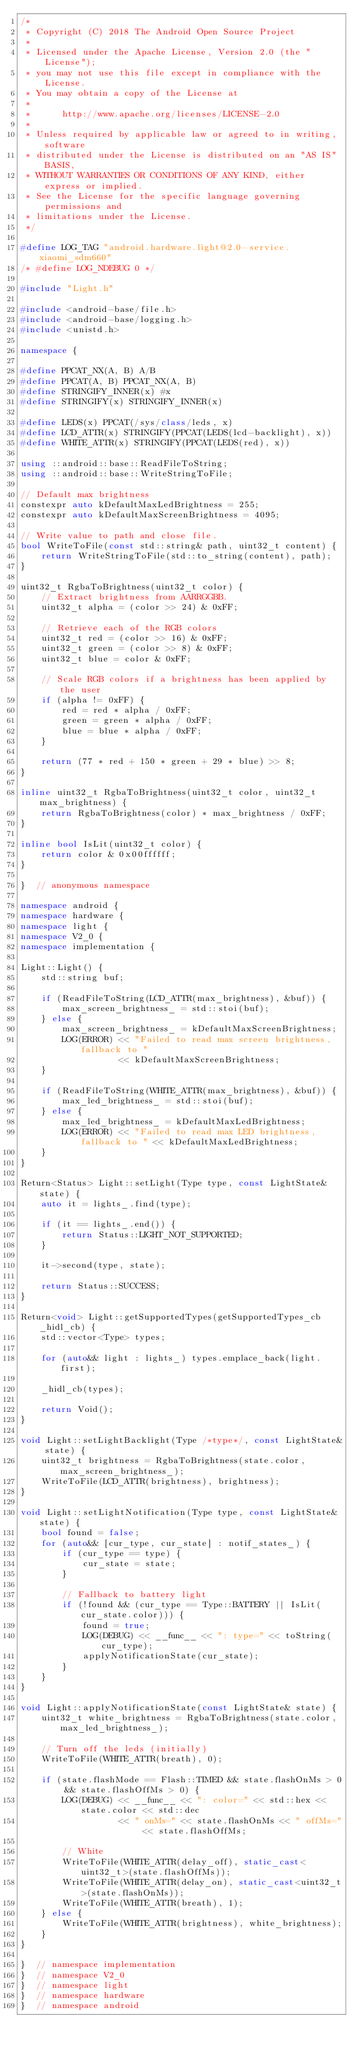Convert code to text. <code><loc_0><loc_0><loc_500><loc_500><_C++_>/*
 * Copyright (C) 2018 The Android Open Source Project
 *
 * Licensed under the Apache License, Version 2.0 (the "License");
 * you may not use this file except in compliance with the License.
 * You may obtain a copy of the License at
 *
 *      http://www.apache.org/licenses/LICENSE-2.0
 *
 * Unless required by applicable law or agreed to in writing, software
 * distributed under the License is distributed on an "AS IS" BASIS,
 * WITHOUT WARRANTIES OR CONDITIONS OF ANY KIND, either express or implied.
 * See the License for the specific language governing permissions and
 * limitations under the License.
 */

#define LOG_TAG "android.hardware.light@2.0-service.xiaomi_sdm660"
/* #define LOG_NDEBUG 0 */

#include "Light.h"

#include <android-base/file.h>
#include <android-base/logging.h>
#include <unistd.h>

namespace {

#define PPCAT_NX(A, B) A/B
#define PPCAT(A, B) PPCAT_NX(A, B)
#define STRINGIFY_INNER(x) #x
#define STRINGIFY(x) STRINGIFY_INNER(x)

#define LEDS(x) PPCAT(/sys/class/leds, x)
#define LCD_ATTR(x) STRINGIFY(PPCAT(LEDS(lcd-backlight), x))
#define WHITE_ATTR(x) STRINGIFY(PPCAT(LEDS(red), x))

using ::android::base::ReadFileToString;
using ::android::base::WriteStringToFile;

// Default max brightness
constexpr auto kDefaultMaxLedBrightness = 255;
constexpr auto kDefaultMaxScreenBrightness = 4095;

// Write value to path and close file.
bool WriteToFile(const std::string& path, uint32_t content) {
    return WriteStringToFile(std::to_string(content), path);
}

uint32_t RgbaToBrightness(uint32_t color) {
    // Extract brightness from AARRGGBB.
    uint32_t alpha = (color >> 24) & 0xFF;

    // Retrieve each of the RGB colors
    uint32_t red = (color >> 16) & 0xFF;
    uint32_t green = (color >> 8) & 0xFF;
    uint32_t blue = color & 0xFF;

    // Scale RGB colors if a brightness has been applied by the user
    if (alpha != 0xFF) {
        red = red * alpha / 0xFF;
        green = green * alpha / 0xFF;
        blue = blue * alpha / 0xFF;
    }

    return (77 * red + 150 * green + 29 * blue) >> 8;
}

inline uint32_t RgbaToBrightness(uint32_t color, uint32_t max_brightness) {
    return RgbaToBrightness(color) * max_brightness / 0xFF;
}

inline bool IsLit(uint32_t color) {
    return color & 0x00ffffff;
}

}  // anonymous namespace

namespace android {
namespace hardware {
namespace light {
namespace V2_0 {
namespace implementation {

Light::Light() {
    std::string buf;

    if (ReadFileToString(LCD_ATTR(max_brightness), &buf)) {
        max_screen_brightness_ = std::stoi(buf);
    } else {
        max_screen_brightness_ = kDefaultMaxScreenBrightness;
        LOG(ERROR) << "Failed to read max screen brightness, fallback to "
                   << kDefaultMaxScreenBrightness;
    }

    if (ReadFileToString(WHITE_ATTR(max_brightness), &buf)) {
        max_led_brightness_ = std::stoi(buf);
    } else {
        max_led_brightness_ = kDefaultMaxLedBrightness;
        LOG(ERROR) << "Failed to read max LED brightness, fallback to " << kDefaultMaxLedBrightness;
    }
}

Return<Status> Light::setLight(Type type, const LightState& state) {
    auto it = lights_.find(type);

    if (it == lights_.end()) {
        return Status::LIGHT_NOT_SUPPORTED;
    }

    it->second(type, state);

    return Status::SUCCESS;
}

Return<void> Light::getSupportedTypes(getSupportedTypes_cb _hidl_cb) {
    std::vector<Type> types;

    for (auto&& light : lights_) types.emplace_back(light.first);

    _hidl_cb(types);

    return Void();
}

void Light::setLightBacklight(Type /*type*/, const LightState& state) {
    uint32_t brightness = RgbaToBrightness(state.color, max_screen_brightness_);
    WriteToFile(LCD_ATTR(brightness), brightness);
}

void Light::setLightNotification(Type type, const LightState& state) {
    bool found = false;
    for (auto&& [cur_type, cur_state] : notif_states_) {
        if (cur_type == type) {
            cur_state = state;
        }

        // Fallback to battery light
        if (!found && (cur_type == Type::BATTERY || IsLit(cur_state.color))) {
            found = true;
            LOG(DEBUG) << __func__ << ": type=" << toString(cur_type);
            applyNotificationState(cur_state);
        }
    }
}

void Light::applyNotificationState(const LightState& state) {
    uint32_t white_brightness = RgbaToBrightness(state.color, max_led_brightness_);

    // Turn off the leds (initially)
    WriteToFile(WHITE_ATTR(breath), 0);

    if (state.flashMode == Flash::TIMED && state.flashOnMs > 0 && state.flashOffMs > 0) {
        LOG(DEBUG) << __func__ << ": color=" << std::hex << state.color << std::dec
                   << " onMs=" << state.flashOnMs << " offMs=" << state.flashOffMs;

        // White
        WriteToFile(WHITE_ATTR(delay_off), static_cast<uint32_t>(state.flashOffMs));
        WriteToFile(WHITE_ATTR(delay_on), static_cast<uint32_t>(state.flashOnMs));
        WriteToFile(WHITE_ATTR(breath), 1);
    } else {
        WriteToFile(WHITE_ATTR(brightness), white_brightness);
    }
}

}  // namespace implementation
}  // namespace V2_0
}  // namespace light
}  // namespace hardware
}  // namespace android
</code> 